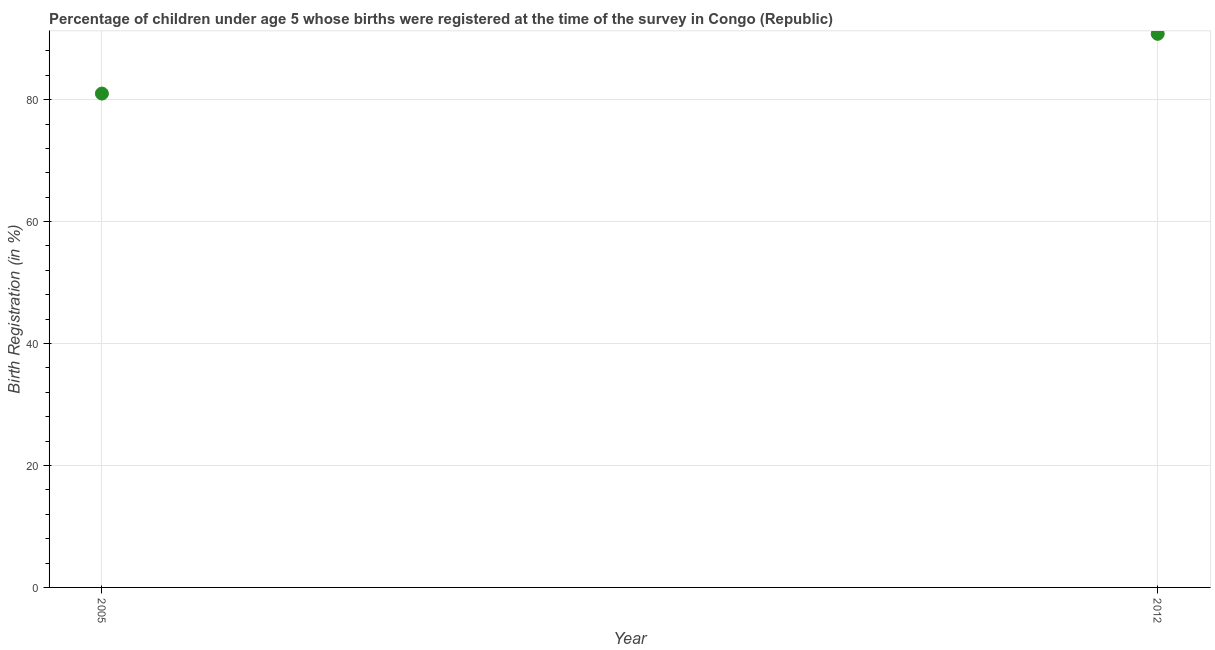What is the birth registration in 2012?
Offer a very short reply. 90.8. Across all years, what is the maximum birth registration?
Your answer should be very brief. 90.8. In which year was the birth registration maximum?
Make the answer very short. 2012. What is the sum of the birth registration?
Your response must be concise. 171.8. What is the difference between the birth registration in 2005 and 2012?
Keep it short and to the point. -9.8. What is the average birth registration per year?
Your answer should be very brief. 85.9. What is the median birth registration?
Ensure brevity in your answer.  85.9. What is the ratio of the birth registration in 2005 to that in 2012?
Provide a succinct answer. 0.89. Is the birth registration in 2005 less than that in 2012?
Provide a short and direct response. Yes. What is the title of the graph?
Keep it short and to the point. Percentage of children under age 5 whose births were registered at the time of the survey in Congo (Republic). What is the label or title of the Y-axis?
Your response must be concise. Birth Registration (in %). What is the Birth Registration (in %) in 2005?
Your answer should be very brief. 81. What is the Birth Registration (in %) in 2012?
Your answer should be very brief. 90.8. What is the ratio of the Birth Registration (in %) in 2005 to that in 2012?
Ensure brevity in your answer.  0.89. 